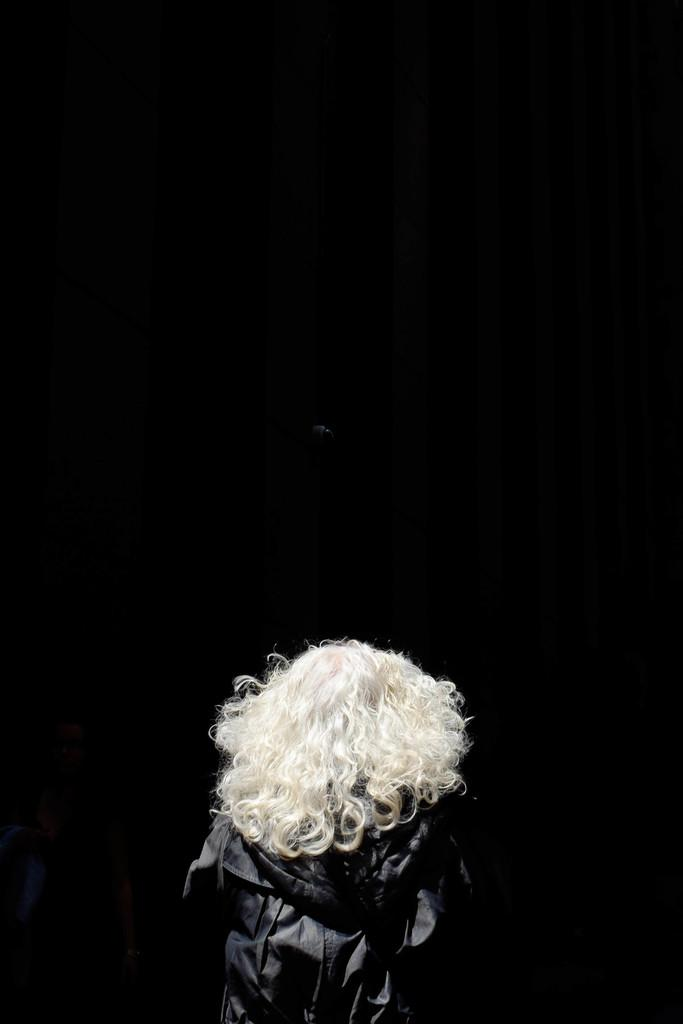What is the overall tone of the image? The image is dark. Can you describe the person in the image? There is a person in the image, and they have white hair. What is the person doing in the image? The person is looking down. What type of bridge can be seen in the image? There is no bridge present in the image. What store is the person standing in front of in the image? There is no store present in the image. 